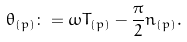Convert formula to latex. <formula><loc_0><loc_0><loc_500><loc_500>\theta _ { ( p ) } \colon = \omega T _ { ( p ) } - \frac { \pi } { 2 } n _ { ( p ) } .</formula> 